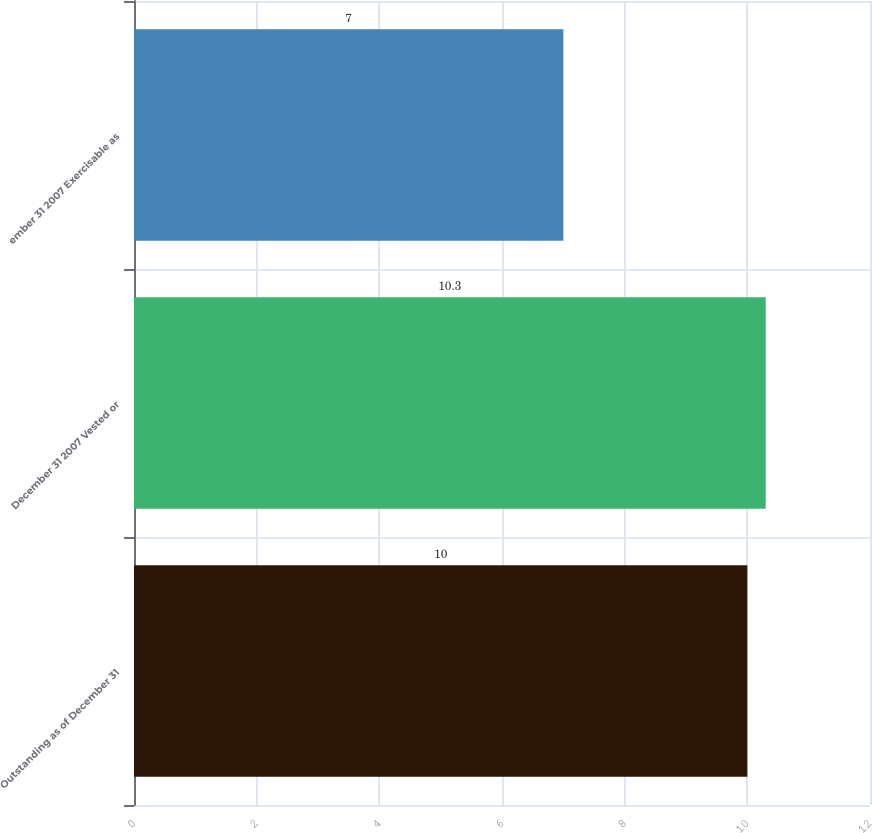Convert chart. <chart><loc_0><loc_0><loc_500><loc_500><bar_chart><fcel>Outstanding as of December 31<fcel>December 31 2007 Vested or<fcel>ember 31 2007 Exercisable as<nl><fcel>10<fcel>10.3<fcel>7<nl></chart> 